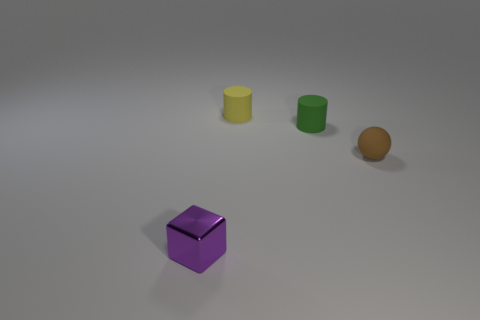Add 2 blue rubber balls. How many objects exist? 6 Subtract 1 cylinders. How many cylinders are left? 1 Subtract all yellow cylinders. How many cylinders are left? 1 Add 3 tiny matte spheres. How many tiny matte spheres are left? 4 Add 4 small blue metal balls. How many small blue metal balls exist? 4 Subtract 0 purple cylinders. How many objects are left? 4 Subtract all cubes. How many objects are left? 3 Subtract all purple cylinders. Subtract all blue blocks. How many cylinders are left? 2 Subtract all big red rubber cylinders. Subtract all matte things. How many objects are left? 1 